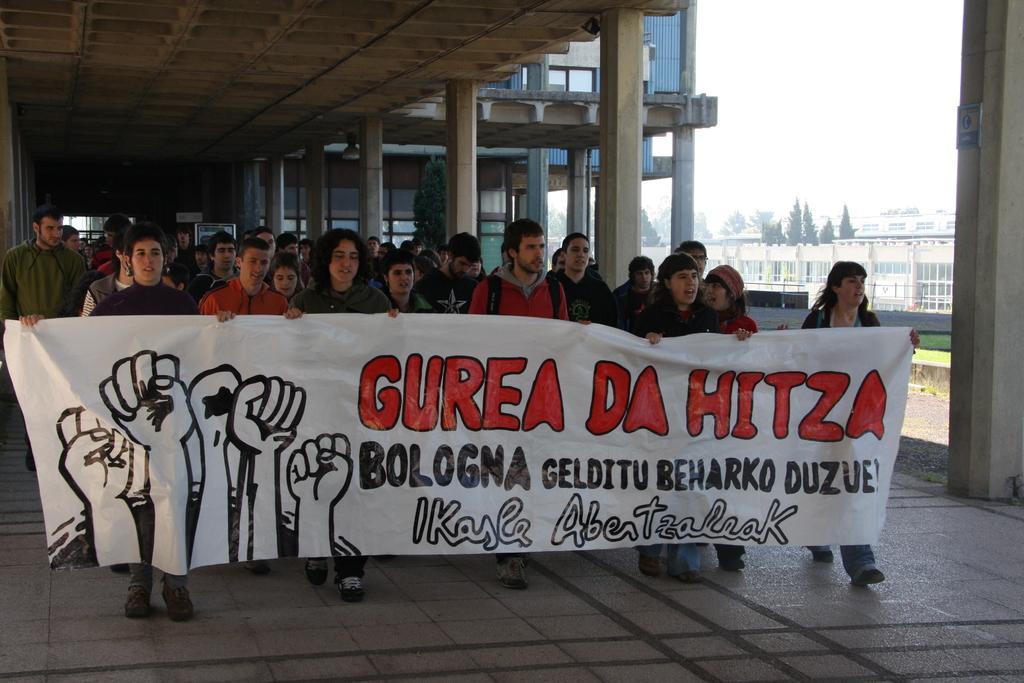Please provide a concise description of this image. There are five persons standing and holding a banner which has some thing written on it and there are few other persons standing behind them and there are trees and buildings in the right corner. 